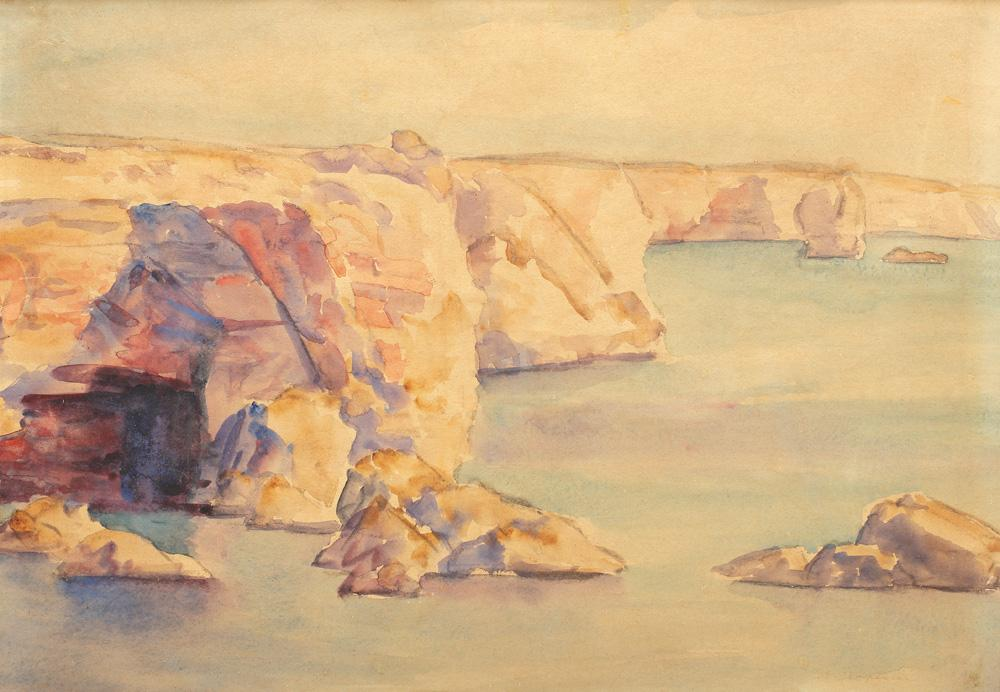What time of day and season might this painting depict, and why do you think this is so? This painting likely depicts a late afternoon, possibly during early fall. The warm hues and soft shadows suggest a setting sun, which is characteristic of the later hours in a day. The light's gentle tone, coupled with the clarity and tranquility of the water, often aligns with early fall, a time when the intense heat of summer tapers off but the starkness of winter hasn't yet begun. 